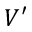<formula> <loc_0><loc_0><loc_500><loc_500>V ^ { \prime }</formula> 